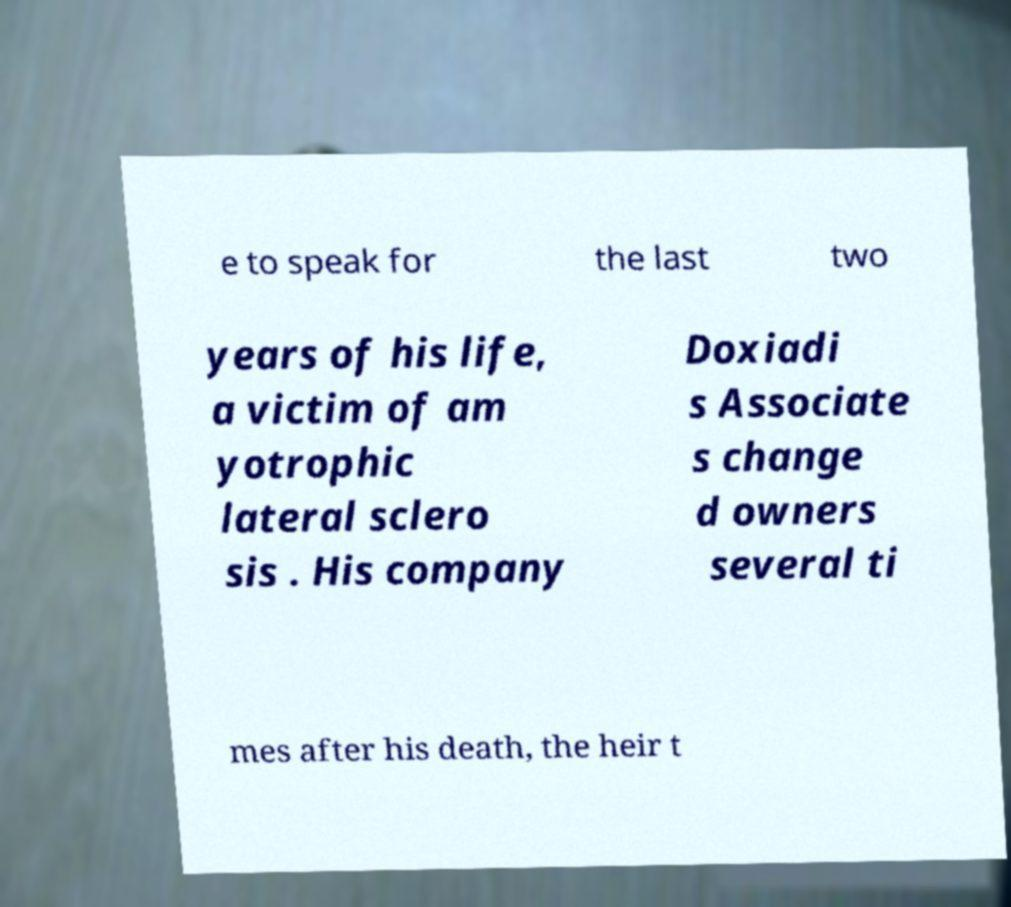What messages or text are displayed in this image? I need them in a readable, typed format. e to speak for the last two years of his life, a victim of am yotrophic lateral sclero sis . His company Doxiadi s Associate s change d owners several ti mes after his death, the heir t 